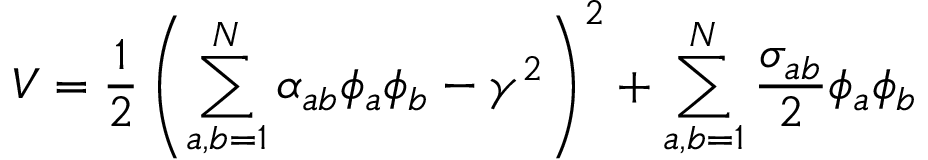Convert formula to latex. <formula><loc_0><loc_0><loc_500><loc_500>V = \frac { 1 } { 2 } \left ( \sum _ { a , b = 1 } ^ { N } \alpha _ { a b } \phi _ { a } \phi _ { b } - \gamma ^ { 2 } \right ) ^ { 2 } + \sum _ { a , b = 1 } ^ { N } \frac { \sigma _ { a b } } { 2 } \phi _ { a } \phi _ { b }</formula> 